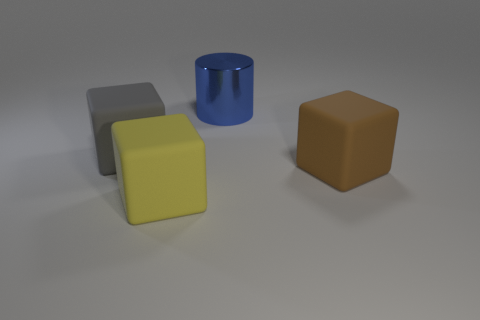What might be the purpose of this arrangement of objects? This arrangement could be for a variety of purposes, such as a render for a 3D modeling project, a study in light and shadow, or a simple display of geometry and color contrasts. 